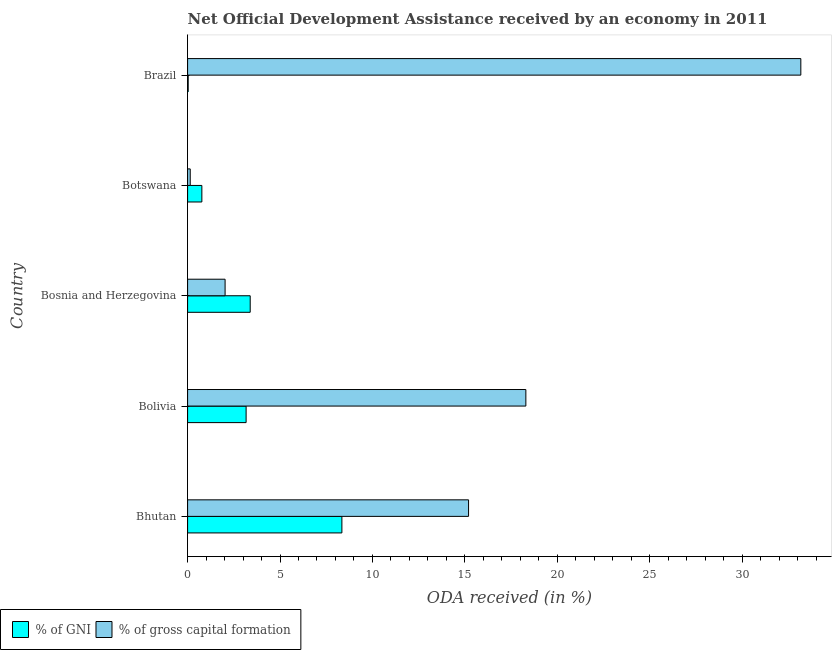How many groups of bars are there?
Offer a terse response. 5. How many bars are there on the 1st tick from the top?
Ensure brevity in your answer.  2. How many bars are there on the 3rd tick from the bottom?
Make the answer very short. 2. What is the label of the 2nd group of bars from the top?
Ensure brevity in your answer.  Botswana. In how many cases, is the number of bars for a given country not equal to the number of legend labels?
Keep it short and to the point. 0. What is the oda received as percentage of gross capital formation in Brazil?
Your answer should be very brief. 33.18. Across all countries, what is the maximum oda received as percentage of gross capital formation?
Offer a very short reply. 33.18. Across all countries, what is the minimum oda received as percentage of gni?
Your response must be concise. 0.03. In which country was the oda received as percentage of gni maximum?
Provide a short and direct response. Bhutan. What is the total oda received as percentage of gni in the graph?
Ensure brevity in your answer.  15.7. What is the difference between the oda received as percentage of gross capital formation in Bolivia and that in Bosnia and Herzegovina?
Offer a terse response. 16.27. What is the difference between the oda received as percentage of gross capital formation in Bhutan and the oda received as percentage of gni in Brazil?
Offer a very short reply. 15.17. What is the average oda received as percentage of gross capital formation per country?
Make the answer very short. 13.77. What is the difference between the oda received as percentage of gni and oda received as percentage of gross capital formation in Botswana?
Offer a terse response. 0.63. What is the ratio of the oda received as percentage of gross capital formation in Bosnia and Herzegovina to that in Brazil?
Your response must be concise. 0.06. What is the difference between the highest and the second highest oda received as percentage of gni?
Your answer should be very brief. 4.96. What is the difference between the highest and the lowest oda received as percentage of gni?
Offer a very short reply. 8.32. In how many countries, is the oda received as percentage of gni greater than the average oda received as percentage of gni taken over all countries?
Make the answer very short. 3. What does the 2nd bar from the top in Brazil represents?
Make the answer very short. % of GNI. What does the 2nd bar from the bottom in Brazil represents?
Your answer should be compact. % of gross capital formation. Are all the bars in the graph horizontal?
Offer a very short reply. Yes. How many countries are there in the graph?
Make the answer very short. 5. Does the graph contain grids?
Your answer should be very brief. No. How many legend labels are there?
Your answer should be compact. 2. What is the title of the graph?
Ensure brevity in your answer.  Net Official Development Assistance received by an economy in 2011. What is the label or title of the X-axis?
Your answer should be compact. ODA received (in %). What is the ODA received (in %) in % of GNI in Bhutan?
Your response must be concise. 8.35. What is the ODA received (in %) in % of gross capital formation in Bhutan?
Your answer should be very brief. 15.2. What is the ODA received (in %) of % of GNI in Bolivia?
Your answer should be very brief. 3.17. What is the ODA received (in %) of % of gross capital formation in Bolivia?
Your answer should be compact. 18.3. What is the ODA received (in %) of % of GNI in Bosnia and Herzegovina?
Keep it short and to the point. 3.39. What is the ODA received (in %) in % of gross capital formation in Bosnia and Herzegovina?
Offer a very short reply. 2.03. What is the ODA received (in %) of % of GNI in Botswana?
Ensure brevity in your answer.  0.77. What is the ODA received (in %) in % of gross capital formation in Botswana?
Provide a succinct answer. 0.14. What is the ODA received (in %) in % of GNI in Brazil?
Your response must be concise. 0.03. What is the ODA received (in %) of % of gross capital formation in Brazil?
Offer a very short reply. 33.18. Across all countries, what is the maximum ODA received (in %) in % of GNI?
Give a very brief answer. 8.35. Across all countries, what is the maximum ODA received (in %) of % of gross capital formation?
Provide a short and direct response. 33.18. Across all countries, what is the minimum ODA received (in %) in % of GNI?
Your response must be concise. 0.03. Across all countries, what is the minimum ODA received (in %) of % of gross capital formation?
Make the answer very short. 0.14. What is the total ODA received (in %) of % of GNI in the graph?
Your response must be concise. 15.7. What is the total ODA received (in %) of % of gross capital formation in the graph?
Your response must be concise. 68.86. What is the difference between the ODA received (in %) of % of GNI in Bhutan and that in Bolivia?
Ensure brevity in your answer.  5.18. What is the difference between the ODA received (in %) in % of gross capital formation in Bhutan and that in Bolivia?
Provide a short and direct response. -3.1. What is the difference between the ODA received (in %) in % of GNI in Bhutan and that in Bosnia and Herzegovina?
Provide a succinct answer. 4.96. What is the difference between the ODA received (in %) in % of gross capital formation in Bhutan and that in Bosnia and Herzegovina?
Offer a terse response. 13.17. What is the difference between the ODA received (in %) in % of GNI in Bhutan and that in Botswana?
Ensure brevity in your answer.  7.58. What is the difference between the ODA received (in %) in % of gross capital formation in Bhutan and that in Botswana?
Your response must be concise. 15.06. What is the difference between the ODA received (in %) in % of GNI in Bhutan and that in Brazil?
Your answer should be very brief. 8.32. What is the difference between the ODA received (in %) of % of gross capital formation in Bhutan and that in Brazil?
Offer a very short reply. -17.98. What is the difference between the ODA received (in %) in % of GNI in Bolivia and that in Bosnia and Herzegovina?
Make the answer very short. -0.22. What is the difference between the ODA received (in %) of % of gross capital formation in Bolivia and that in Bosnia and Herzegovina?
Provide a succinct answer. 16.27. What is the difference between the ODA received (in %) in % of GNI in Bolivia and that in Botswana?
Make the answer very short. 2.39. What is the difference between the ODA received (in %) of % of gross capital formation in Bolivia and that in Botswana?
Give a very brief answer. 18.16. What is the difference between the ODA received (in %) in % of GNI in Bolivia and that in Brazil?
Offer a terse response. 3.13. What is the difference between the ODA received (in %) in % of gross capital formation in Bolivia and that in Brazil?
Keep it short and to the point. -14.88. What is the difference between the ODA received (in %) in % of GNI in Bosnia and Herzegovina and that in Botswana?
Provide a succinct answer. 2.62. What is the difference between the ODA received (in %) of % of gross capital formation in Bosnia and Herzegovina and that in Botswana?
Keep it short and to the point. 1.89. What is the difference between the ODA received (in %) in % of GNI in Bosnia and Herzegovina and that in Brazil?
Ensure brevity in your answer.  3.36. What is the difference between the ODA received (in %) in % of gross capital formation in Bosnia and Herzegovina and that in Brazil?
Provide a succinct answer. -31.15. What is the difference between the ODA received (in %) in % of GNI in Botswana and that in Brazil?
Give a very brief answer. 0.74. What is the difference between the ODA received (in %) in % of gross capital formation in Botswana and that in Brazil?
Give a very brief answer. -33.04. What is the difference between the ODA received (in %) of % of GNI in Bhutan and the ODA received (in %) of % of gross capital formation in Bolivia?
Provide a short and direct response. -9.95. What is the difference between the ODA received (in %) of % of GNI in Bhutan and the ODA received (in %) of % of gross capital formation in Bosnia and Herzegovina?
Provide a succinct answer. 6.32. What is the difference between the ODA received (in %) in % of GNI in Bhutan and the ODA received (in %) in % of gross capital formation in Botswana?
Keep it short and to the point. 8.2. What is the difference between the ODA received (in %) of % of GNI in Bhutan and the ODA received (in %) of % of gross capital formation in Brazil?
Keep it short and to the point. -24.83. What is the difference between the ODA received (in %) in % of GNI in Bolivia and the ODA received (in %) in % of gross capital formation in Bosnia and Herzegovina?
Your answer should be very brief. 1.14. What is the difference between the ODA received (in %) in % of GNI in Bolivia and the ODA received (in %) in % of gross capital formation in Botswana?
Make the answer very short. 3.02. What is the difference between the ODA received (in %) of % of GNI in Bolivia and the ODA received (in %) of % of gross capital formation in Brazil?
Make the answer very short. -30.01. What is the difference between the ODA received (in %) of % of GNI in Bosnia and Herzegovina and the ODA received (in %) of % of gross capital formation in Botswana?
Ensure brevity in your answer.  3.24. What is the difference between the ODA received (in %) in % of GNI in Bosnia and Herzegovina and the ODA received (in %) in % of gross capital formation in Brazil?
Keep it short and to the point. -29.79. What is the difference between the ODA received (in %) in % of GNI in Botswana and the ODA received (in %) in % of gross capital formation in Brazil?
Give a very brief answer. -32.41. What is the average ODA received (in %) of % of GNI per country?
Give a very brief answer. 3.14. What is the average ODA received (in %) in % of gross capital formation per country?
Provide a succinct answer. 13.77. What is the difference between the ODA received (in %) of % of GNI and ODA received (in %) of % of gross capital formation in Bhutan?
Your answer should be very brief. -6.85. What is the difference between the ODA received (in %) of % of GNI and ODA received (in %) of % of gross capital formation in Bolivia?
Your response must be concise. -15.14. What is the difference between the ODA received (in %) of % of GNI and ODA received (in %) of % of gross capital formation in Bosnia and Herzegovina?
Your answer should be compact. 1.36. What is the difference between the ODA received (in %) of % of GNI and ODA received (in %) of % of gross capital formation in Botswana?
Make the answer very short. 0.63. What is the difference between the ODA received (in %) of % of GNI and ODA received (in %) of % of gross capital formation in Brazil?
Provide a short and direct response. -33.15. What is the ratio of the ODA received (in %) in % of GNI in Bhutan to that in Bolivia?
Offer a very short reply. 2.64. What is the ratio of the ODA received (in %) in % of gross capital formation in Bhutan to that in Bolivia?
Keep it short and to the point. 0.83. What is the ratio of the ODA received (in %) in % of GNI in Bhutan to that in Bosnia and Herzegovina?
Ensure brevity in your answer.  2.46. What is the ratio of the ODA received (in %) of % of gross capital formation in Bhutan to that in Bosnia and Herzegovina?
Your answer should be very brief. 7.49. What is the ratio of the ODA received (in %) in % of GNI in Bhutan to that in Botswana?
Keep it short and to the point. 10.82. What is the ratio of the ODA received (in %) in % of gross capital formation in Bhutan to that in Botswana?
Provide a succinct answer. 106.32. What is the ratio of the ODA received (in %) in % of GNI in Bhutan to that in Brazil?
Provide a succinct answer. 263.18. What is the ratio of the ODA received (in %) of % of gross capital formation in Bhutan to that in Brazil?
Your answer should be very brief. 0.46. What is the ratio of the ODA received (in %) of % of GNI in Bolivia to that in Bosnia and Herzegovina?
Your response must be concise. 0.93. What is the ratio of the ODA received (in %) in % of gross capital formation in Bolivia to that in Bosnia and Herzegovina?
Provide a succinct answer. 9.02. What is the ratio of the ODA received (in %) of % of GNI in Bolivia to that in Botswana?
Make the answer very short. 4.1. What is the ratio of the ODA received (in %) of % of gross capital formation in Bolivia to that in Botswana?
Make the answer very short. 128. What is the ratio of the ODA received (in %) in % of GNI in Bolivia to that in Brazil?
Ensure brevity in your answer.  99.8. What is the ratio of the ODA received (in %) of % of gross capital formation in Bolivia to that in Brazil?
Your response must be concise. 0.55. What is the ratio of the ODA received (in %) in % of GNI in Bosnia and Herzegovina to that in Botswana?
Offer a terse response. 4.39. What is the ratio of the ODA received (in %) in % of gross capital formation in Bosnia and Herzegovina to that in Botswana?
Make the answer very short. 14.19. What is the ratio of the ODA received (in %) in % of GNI in Bosnia and Herzegovina to that in Brazil?
Provide a short and direct response. 106.79. What is the ratio of the ODA received (in %) in % of gross capital formation in Bosnia and Herzegovina to that in Brazil?
Keep it short and to the point. 0.06. What is the ratio of the ODA received (in %) in % of GNI in Botswana to that in Brazil?
Ensure brevity in your answer.  24.33. What is the ratio of the ODA received (in %) of % of gross capital formation in Botswana to that in Brazil?
Offer a terse response. 0. What is the difference between the highest and the second highest ODA received (in %) in % of GNI?
Your answer should be compact. 4.96. What is the difference between the highest and the second highest ODA received (in %) in % of gross capital formation?
Ensure brevity in your answer.  14.88. What is the difference between the highest and the lowest ODA received (in %) in % of GNI?
Offer a very short reply. 8.32. What is the difference between the highest and the lowest ODA received (in %) of % of gross capital formation?
Make the answer very short. 33.04. 